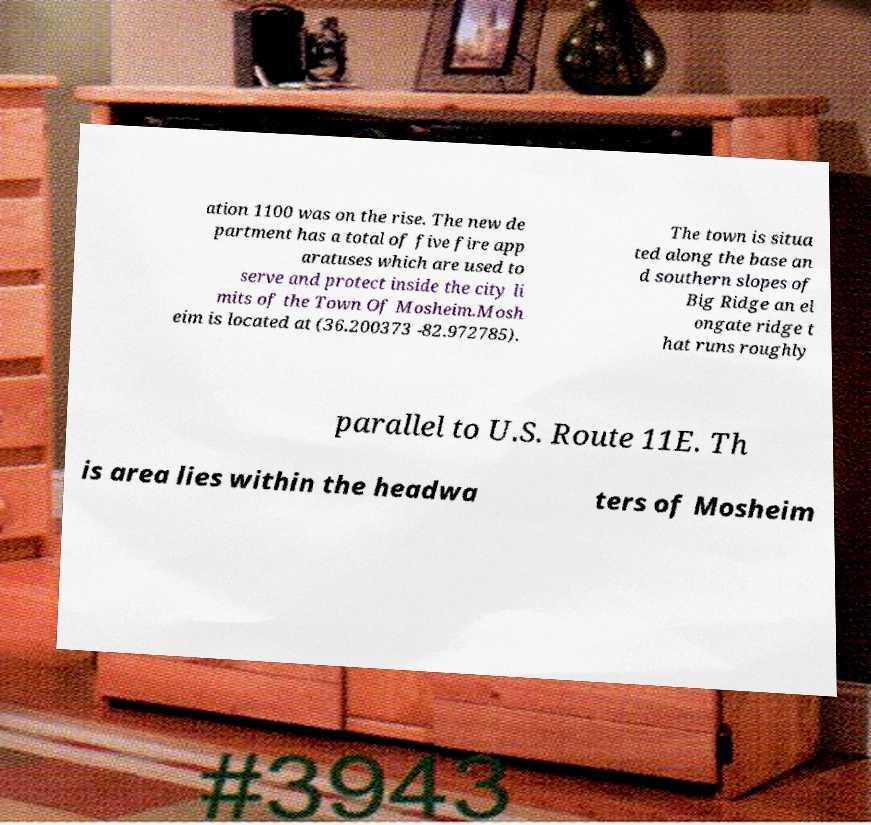Please read and relay the text visible in this image. What does it say? ation 1100 was on the rise. The new de partment has a total of five fire app aratuses which are used to serve and protect inside the city li mits of the Town Of Mosheim.Mosh eim is located at (36.200373 -82.972785). The town is situa ted along the base an d southern slopes of Big Ridge an el ongate ridge t hat runs roughly parallel to U.S. Route 11E. Th is area lies within the headwa ters of Mosheim 